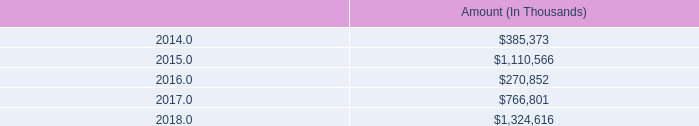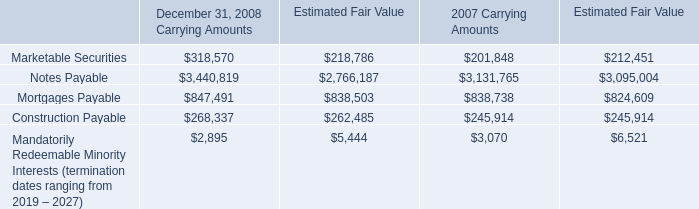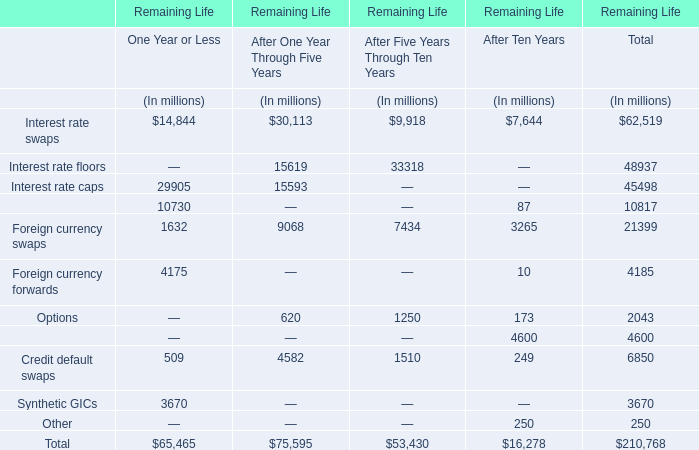what is the highest total amount of Credit default swaps for Remaining Life? (in million) 
Answer: 4582. 